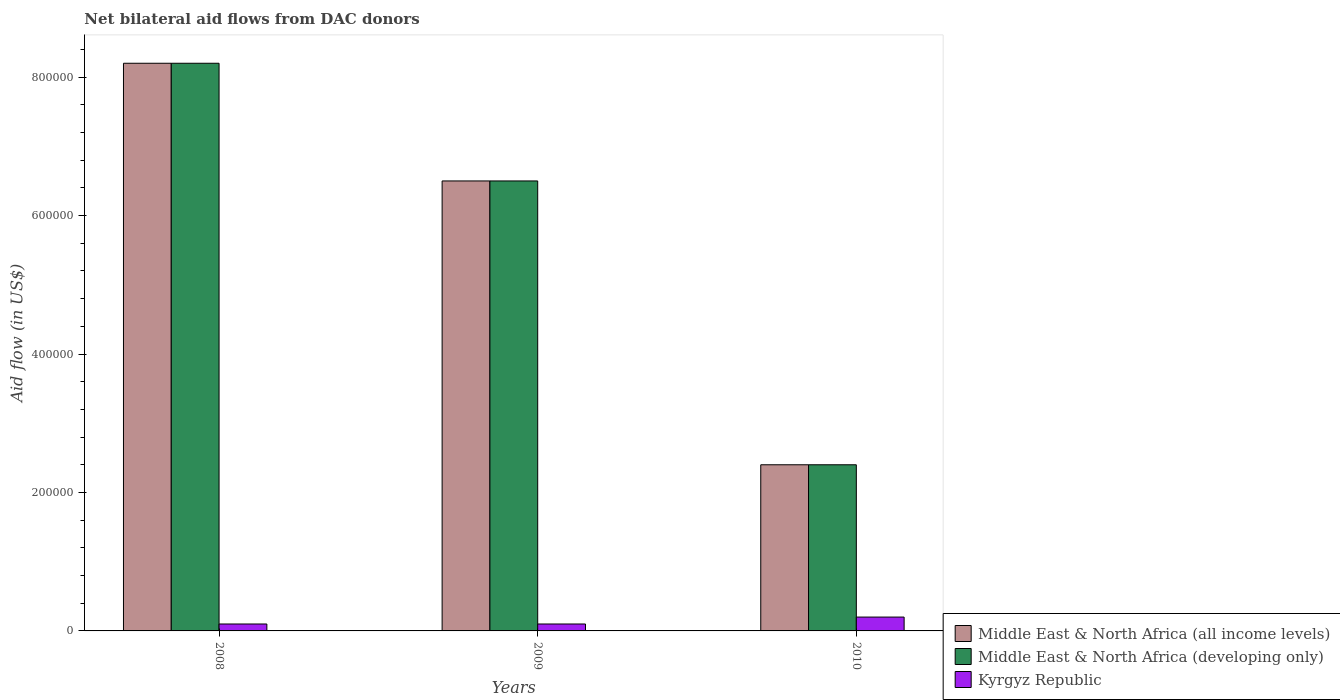Are the number of bars per tick equal to the number of legend labels?
Provide a short and direct response. Yes. How many bars are there on the 3rd tick from the left?
Offer a terse response. 3. How many bars are there on the 2nd tick from the right?
Provide a short and direct response. 3. What is the net bilateral aid flow in Middle East & North Africa (developing only) in 2008?
Your response must be concise. 8.20e+05. Across all years, what is the maximum net bilateral aid flow in Middle East & North Africa (developing only)?
Make the answer very short. 8.20e+05. Across all years, what is the minimum net bilateral aid flow in Middle East & North Africa (all income levels)?
Give a very brief answer. 2.40e+05. In which year was the net bilateral aid flow in Middle East & North Africa (all income levels) maximum?
Your response must be concise. 2008. What is the total net bilateral aid flow in Middle East & North Africa (all income levels) in the graph?
Your answer should be very brief. 1.71e+06. What is the difference between the net bilateral aid flow in Middle East & North Africa (all income levels) in 2008 and that in 2009?
Your answer should be compact. 1.70e+05. What is the average net bilateral aid flow in Middle East & North Africa (developing only) per year?
Provide a succinct answer. 5.70e+05. In the year 2009, what is the difference between the net bilateral aid flow in Middle East & North Africa (developing only) and net bilateral aid flow in Kyrgyz Republic?
Your response must be concise. 6.40e+05. What is the difference between the highest and the lowest net bilateral aid flow in Middle East & North Africa (all income levels)?
Give a very brief answer. 5.80e+05. Is the sum of the net bilateral aid flow in Kyrgyz Republic in 2008 and 2010 greater than the maximum net bilateral aid flow in Middle East & North Africa (developing only) across all years?
Offer a terse response. No. What does the 2nd bar from the left in 2009 represents?
Provide a succinct answer. Middle East & North Africa (developing only). What does the 3rd bar from the right in 2009 represents?
Provide a succinct answer. Middle East & North Africa (all income levels). Is it the case that in every year, the sum of the net bilateral aid flow in Kyrgyz Republic and net bilateral aid flow in Middle East & North Africa (all income levels) is greater than the net bilateral aid flow in Middle East & North Africa (developing only)?
Make the answer very short. Yes. Are all the bars in the graph horizontal?
Your answer should be compact. No. What is the difference between two consecutive major ticks on the Y-axis?
Your response must be concise. 2.00e+05. Does the graph contain grids?
Your response must be concise. No. Where does the legend appear in the graph?
Your response must be concise. Bottom right. How many legend labels are there?
Provide a succinct answer. 3. How are the legend labels stacked?
Make the answer very short. Vertical. What is the title of the graph?
Keep it short and to the point. Net bilateral aid flows from DAC donors. What is the label or title of the X-axis?
Offer a very short reply. Years. What is the label or title of the Y-axis?
Give a very brief answer. Aid flow (in US$). What is the Aid flow (in US$) in Middle East & North Africa (all income levels) in 2008?
Your answer should be compact. 8.20e+05. What is the Aid flow (in US$) in Middle East & North Africa (developing only) in 2008?
Make the answer very short. 8.20e+05. What is the Aid flow (in US$) of Middle East & North Africa (all income levels) in 2009?
Provide a succinct answer. 6.50e+05. What is the Aid flow (in US$) in Middle East & North Africa (developing only) in 2009?
Provide a short and direct response. 6.50e+05. What is the Aid flow (in US$) in Kyrgyz Republic in 2009?
Provide a succinct answer. 10000. What is the Aid flow (in US$) in Middle East & North Africa (all income levels) in 2010?
Ensure brevity in your answer.  2.40e+05. What is the Aid flow (in US$) of Middle East & North Africa (developing only) in 2010?
Provide a succinct answer. 2.40e+05. Across all years, what is the maximum Aid flow (in US$) of Middle East & North Africa (all income levels)?
Keep it short and to the point. 8.20e+05. Across all years, what is the maximum Aid flow (in US$) of Middle East & North Africa (developing only)?
Give a very brief answer. 8.20e+05. Across all years, what is the minimum Aid flow (in US$) of Middle East & North Africa (all income levels)?
Make the answer very short. 2.40e+05. Across all years, what is the minimum Aid flow (in US$) in Kyrgyz Republic?
Provide a succinct answer. 10000. What is the total Aid flow (in US$) in Middle East & North Africa (all income levels) in the graph?
Make the answer very short. 1.71e+06. What is the total Aid flow (in US$) in Middle East & North Africa (developing only) in the graph?
Make the answer very short. 1.71e+06. What is the difference between the Aid flow (in US$) in Middle East & North Africa (all income levels) in 2008 and that in 2009?
Give a very brief answer. 1.70e+05. What is the difference between the Aid flow (in US$) of Kyrgyz Republic in 2008 and that in 2009?
Provide a short and direct response. 0. What is the difference between the Aid flow (in US$) in Middle East & North Africa (all income levels) in 2008 and that in 2010?
Offer a terse response. 5.80e+05. What is the difference between the Aid flow (in US$) of Middle East & North Africa (developing only) in 2008 and that in 2010?
Ensure brevity in your answer.  5.80e+05. What is the difference between the Aid flow (in US$) of Kyrgyz Republic in 2008 and that in 2010?
Ensure brevity in your answer.  -10000. What is the difference between the Aid flow (in US$) of Kyrgyz Republic in 2009 and that in 2010?
Offer a terse response. -10000. What is the difference between the Aid flow (in US$) of Middle East & North Africa (all income levels) in 2008 and the Aid flow (in US$) of Middle East & North Africa (developing only) in 2009?
Provide a short and direct response. 1.70e+05. What is the difference between the Aid flow (in US$) in Middle East & North Africa (all income levels) in 2008 and the Aid flow (in US$) in Kyrgyz Republic in 2009?
Offer a very short reply. 8.10e+05. What is the difference between the Aid flow (in US$) of Middle East & North Africa (developing only) in 2008 and the Aid flow (in US$) of Kyrgyz Republic in 2009?
Offer a terse response. 8.10e+05. What is the difference between the Aid flow (in US$) in Middle East & North Africa (all income levels) in 2008 and the Aid flow (in US$) in Middle East & North Africa (developing only) in 2010?
Your answer should be very brief. 5.80e+05. What is the difference between the Aid flow (in US$) in Middle East & North Africa (developing only) in 2008 and the Aid flow (in US$) in Kyrgyz Republic in 2010?
Make the answer very short. 8.00e+05. What is the difference between the Aid flow (in US$) of Middle East & North Africa (all income levels) in 2009 and the Aid flow (in US$) of Middle East & North Africa (developing only) in 2010?
Provide a short and direct response. 4.10e+05. What is the difference between the Aid flow (in US$) of Middle East & North Africa (all income levels) in 2009 and the Aid flow (in US$) of Kyrgyz Republic in 2010?
Your response must be concise. 6.30e+05. What is the difference between the Aid flow (in US$) in Middle East & North Africa (developing only) in 2009 and the Aid flow (in US$) in Kyrgyz Republic in 2010?
Offer a very short reply. 6.30e+05. What is the average Aid flow (in US$) of Middle East & North Africa (all income levels) per year?
Make the answer very short. 5.70e+05. What is the average Aid flow (in US$) of Middle East & North Africa (developing only) per year?
Your answer should be very brief. 5.70e+05. What is the average Aid flow (in US$) in Kyrgyz Republic per year?
Your answer should be very brief. 1.33e+04. In the year 2008, what is the difference between the Aid flow (in US$) in Middle East & North Africa (all income levels) and Aid flow (in US$) in Middle East & North Africa (developing only)?
Make the answer very short. 0. In the year 2008, what is the difference between the Aid flow (in US$) of Middle East & North Africa (all income levels) and Aid flow (in US$) of Kyrgyz Republic?
Provide a succinct answer. 8.10e+05. In the year 2008, what is the difference between the Aid flow (in US$) of Middle East & North Africa (developing only) and Aid flow (in US$) of Kyrgyz Republic?
Ensure brevity in your answer.  8.10e+05. In the year 2009, what is the difference between the Aid flow (in US$) in Middle East & North Africa (all income levels) and Aid flow (in US$) in Kyrgyz Republic?
Offer a very short reply. 6.40e+05. In the year 2009, what is the difference between the Aid flow (in US$) of Middle East & North Africa (developing only) and Aid flow (in US$) of Kyrgyz Republic?
Provide a short and direct response. 6.40e+05. In the year 2010, what is the difference between the Aid flow (in US$) of Middle East & North Africa (all income levels) and Aid flow (in US$) of Middle East & North Africa (developing only)?
Offer a very short reply. 0. In the year 2010, what is the difference between the Aid flow (in US$) in Middle East & North Africa (all income levels) and Aid flow (in US$) in Kyrgyz Republic?
Your response must be concise. 2.20e+05. What is the ratio of the Aid flow (in US$) of Middle East & North Africa (all income levels) in 2008 to that in 2009?
Offer a very short reply. 1.26. What is the ratio of the Aid flow (in US$) in Middle East & North Africa (developing only) in 2008 to that in 2009?
Your response must be concise. 1.26. What is the ratio of the Aid flow (in US$) of Middle East & North Africa (all income levels) in 2008 to that in 2010?
Make the answer very short. 3.42. What is the ratio of the Aid flow (in US$) of Middle East & North Africa (developing only) in 2008 to that in 2010?
Make the answer very short. 3.42. What is the ratio of the Aid flow (in US$) in Kyrgyz Republic in 2008 to that in 2010?
Keep it short and to the point. 0.5. What is the ratio of the Aid flow (in US$) of Middle East & North Africa (all income levels) in 2009 to that in 2010?
Keep it short and to the point. 2.71. What is the ratio of the Aid flow (in US$) in Middle East & North Africa (developing only) in 2009 to that in 2010?
Provide a succinct answer. 2.71. What is the ratio of the Aid flow (in US$) of Kyrgyz Republic in 2009 to that in 2010?
Ensure brevity in your answer.  0.5. What is the difference between the highest and the lowest Aid flow (in US$) in Middle East & North Africa (all income levels)?
Keep it short and to the point. 5.80e+05. What is the difference between the highest and the lowest Aid flow (in US$) in Middle East & North Africa (developing only)?
Offer a very short reply. 5.80e+05. What is the difference between the highest and the lowest Aid flow (in US$) in Kyrgyz Republic?
Provide a short and direct response. 10000. 